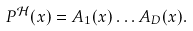<formula> <loc_0><loc_0><loc_500><loc_500>P ^ { \mathcal { H } } ( x ) = A _ { 1 } ( x ) \dots A _ { D } ( x ) .</formula> 